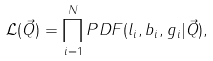Convert formula to latex. <formula><loc_0><loc_0><loc_500><loc_500>\mathcal { L } ( \vec { Q } ) = \prod _ { i = 1 } ^ { N } P D F ( l _ { i } , b _ { i } , g _ { i } | \vec { Q } ) ,</formula> 